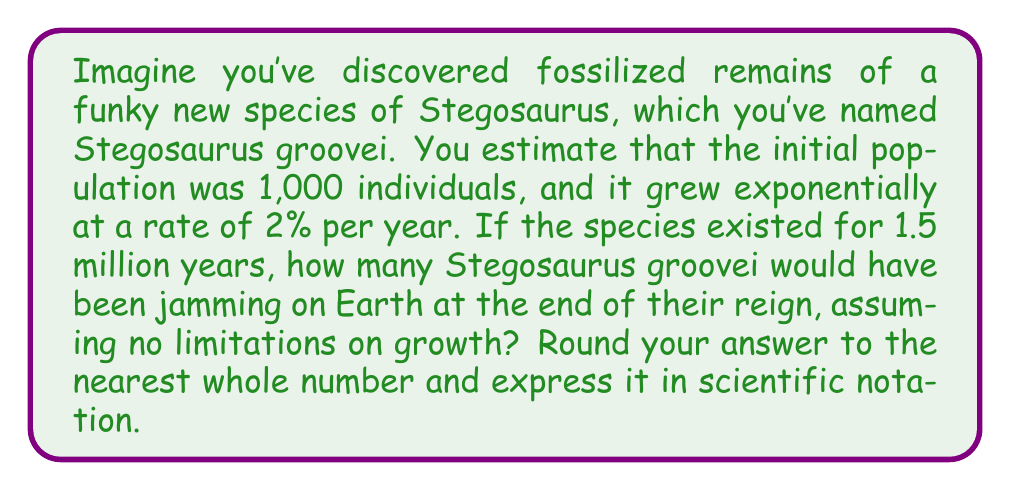Could you help me with this problem? Let's break this down step-by-step:

1) We're dealing with exponential growth, which can be modeled by the equation:

   $$P(t) = P_0 \cdot e^{rt}$$

   Where:
   $P(t)$ is the population at time $t$
   $P_0$ is the initial population
   $r$ is the growth rate
   $t$ is the time period

2) We're given:
   $P_0 = 1,000$
   $r = 0.02$ (2% expressed as a decimal)
   $t = 1,500,000$ years

3) Let's plug these values into our equation:

   $$P(1,500,000) = 1,000 \cdot e^{0.02 \cdot 1,500,000}$$

4) Now, let's calculate the exponent:

   $$0.02 \cdot 1,500,000 = 30,000$$

5) Our equation now looks like:

   $$P(1,500,000) = 1,000 \cdot e^{30,000}$$

6) Using a calculator (as this number is astronomically large):

   $$P(1,500,000) \approx 1.0686 \times 10^{13031}$$

7) Rounding to the nearest whole number doesn't change this value in scientific notation.

This result indicates an impossibly large number of dinosaurs, highlighting the importance of considering limiting factors in population growth models. In reality, factors like food availability, predation, and habitat constraints would have limited the population's growth.
Answer: $1.0686 \times 10^{13031}$ 